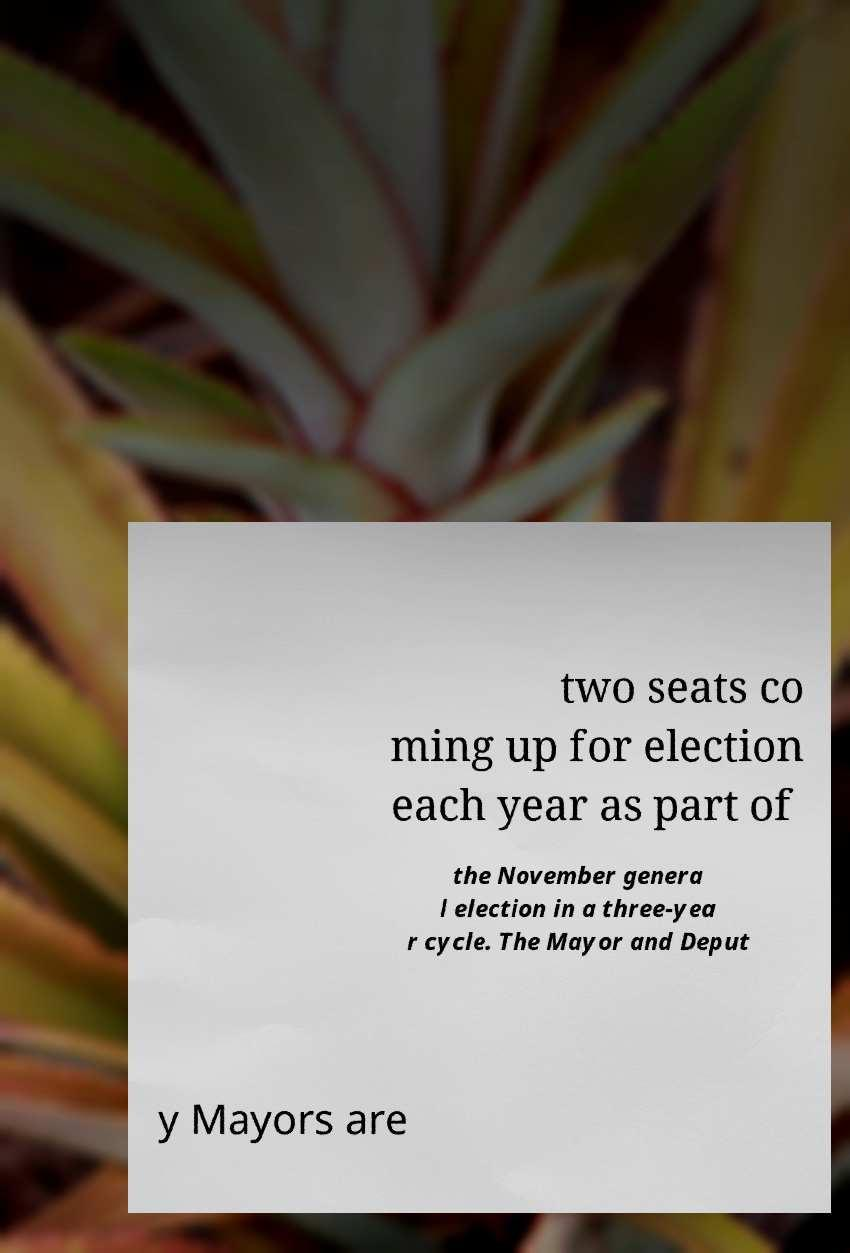Please read and relay the text visible in this image. What does it say? two seats co ming up for election each year as part of the November genera l election in a three-yea r cycle. The Mayor and Deput y Mayors are 